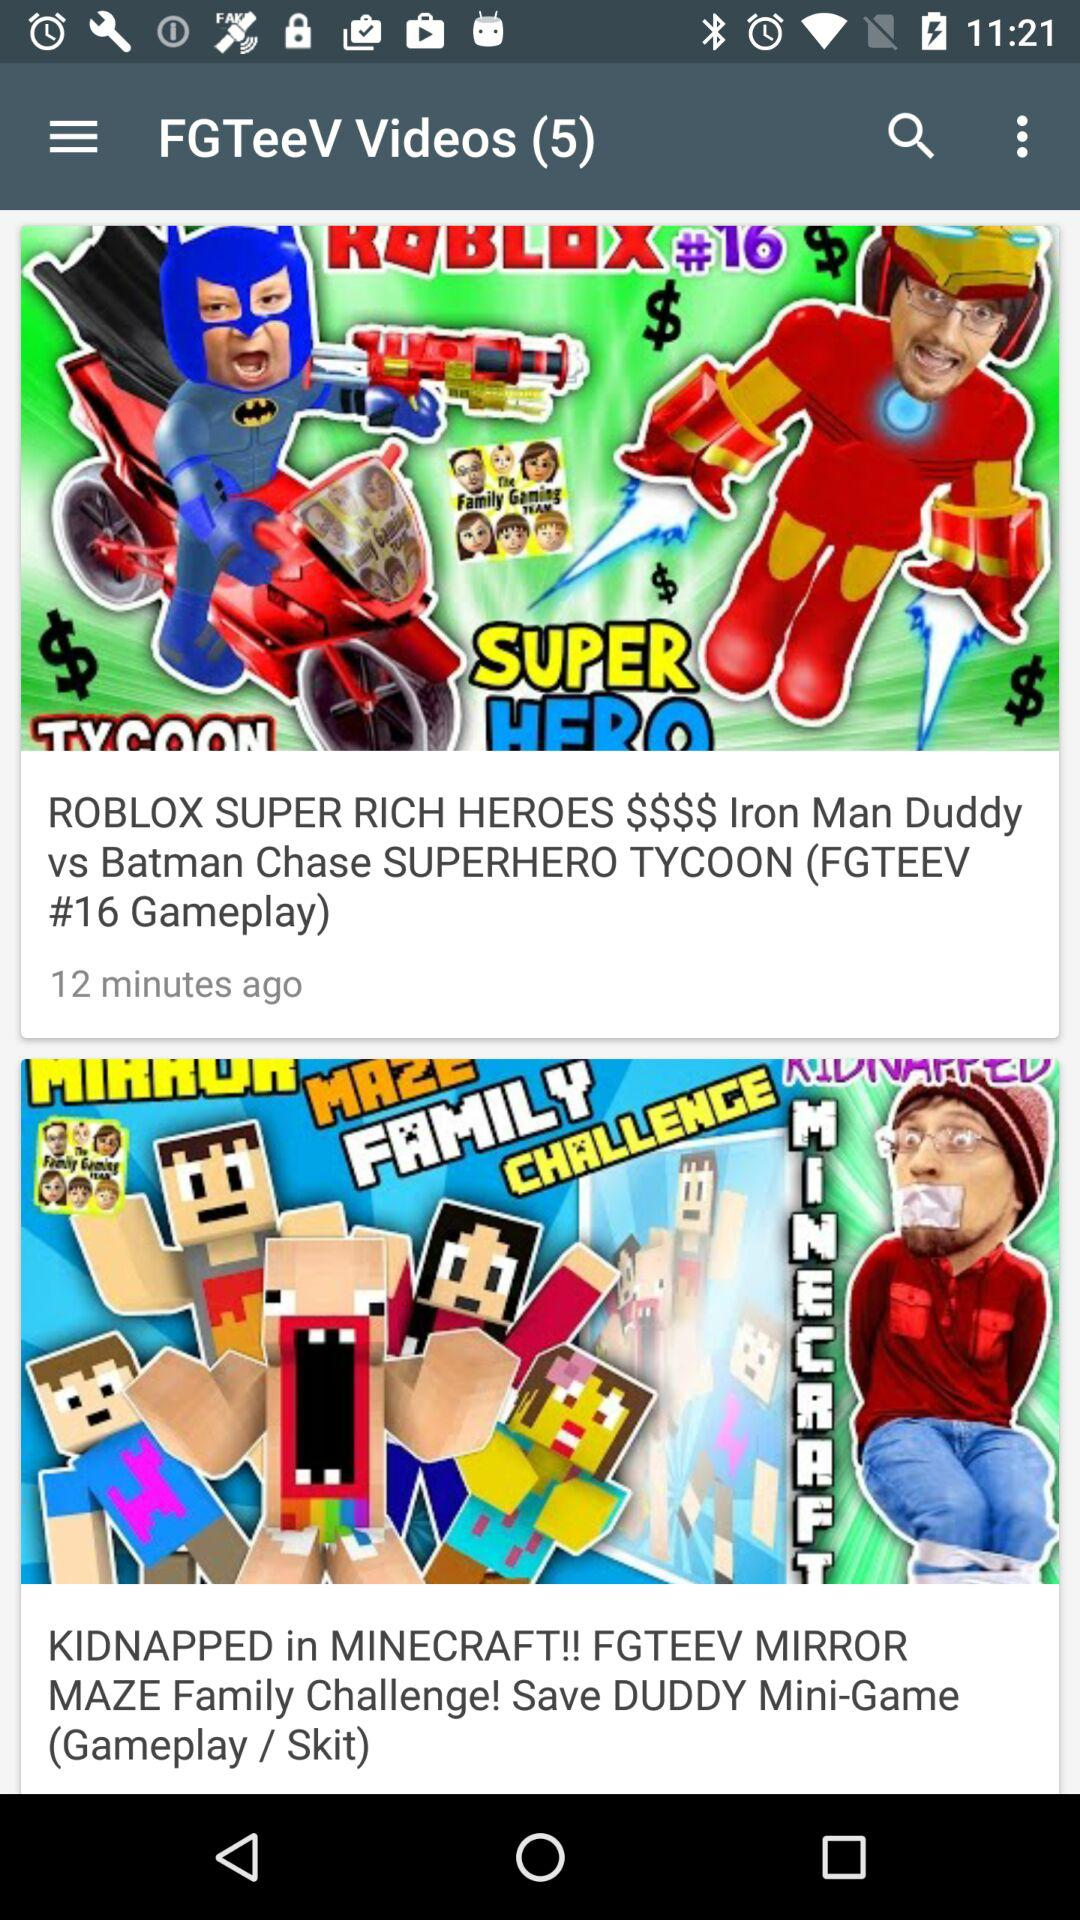How many minutes ago was the "FGTEEV #16 gameplay video uploaded"? The video was uploaded 12 minutes ago. 